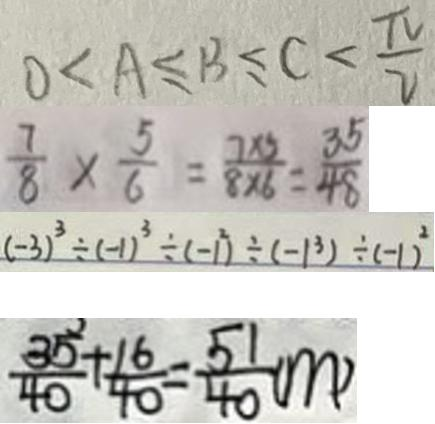Convert formula to latex. <formula><loc_0><loc_0><loc_500><loc_500>0 < A \leq B \leq c < \frac { \pi } { 2 } 
 \frac { 7 } { 8 } \times \frac { 5 } { 6 } = \frac { 7 \times 5 } { 8 \times 6 } = \frac { 3 5 } { 4 8 } 
 ( - 3 ) ^ { 3 } \div ( - 1 ) ^ { 3 } \div ( - 1 ^ { 2 } ) \div ( - 1 ^ { 3 } ) \div ( - 1 ) ^ { 2 } 
 \frac { 3 5 } { 4 0 } + \frac { 1 6 } { 4 0 } = \frac { 5 1 } { 4 0 } ( m )</formula> 